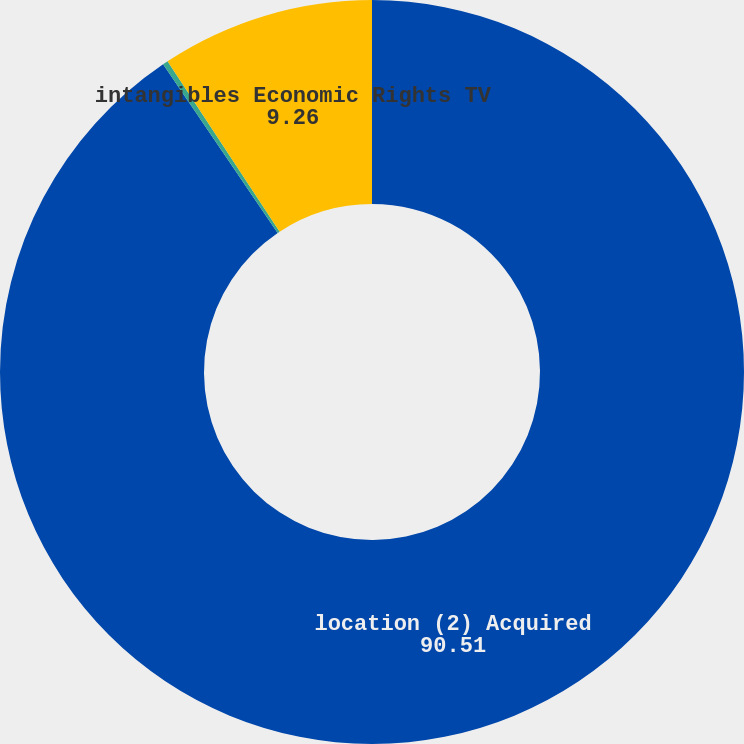Convert chart. <chart><loc_0><loc_0><loc_500><loc_500><pie_chart><fcel>location (2) Acquired<fcel>intangibles Acquired licenses<fcel>intangibles Economic Rights TV<nl><fcel>90.51%<fcel>0.23%<fcel>9.26%<nl></chart> 